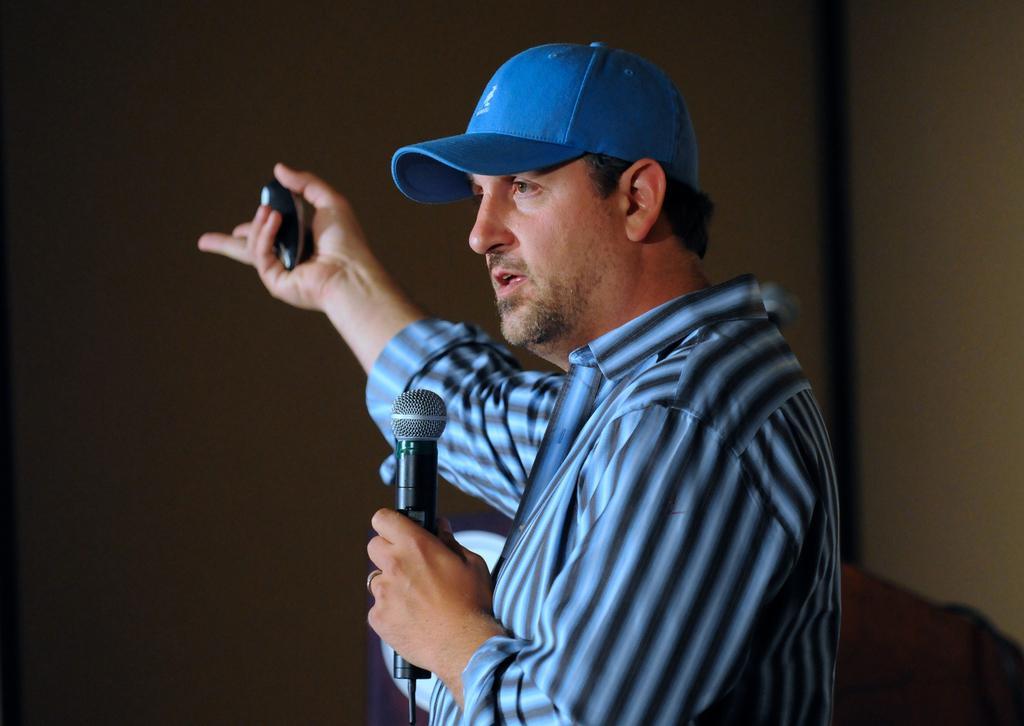Describe this image in one or two sentences. In this image I see a man who is wearing shirt which is of black and blue in color and I see that he is holding a mic in one hand and a thing in other hand and I see that he is wearing a blue cap. In the background I see the wall. 